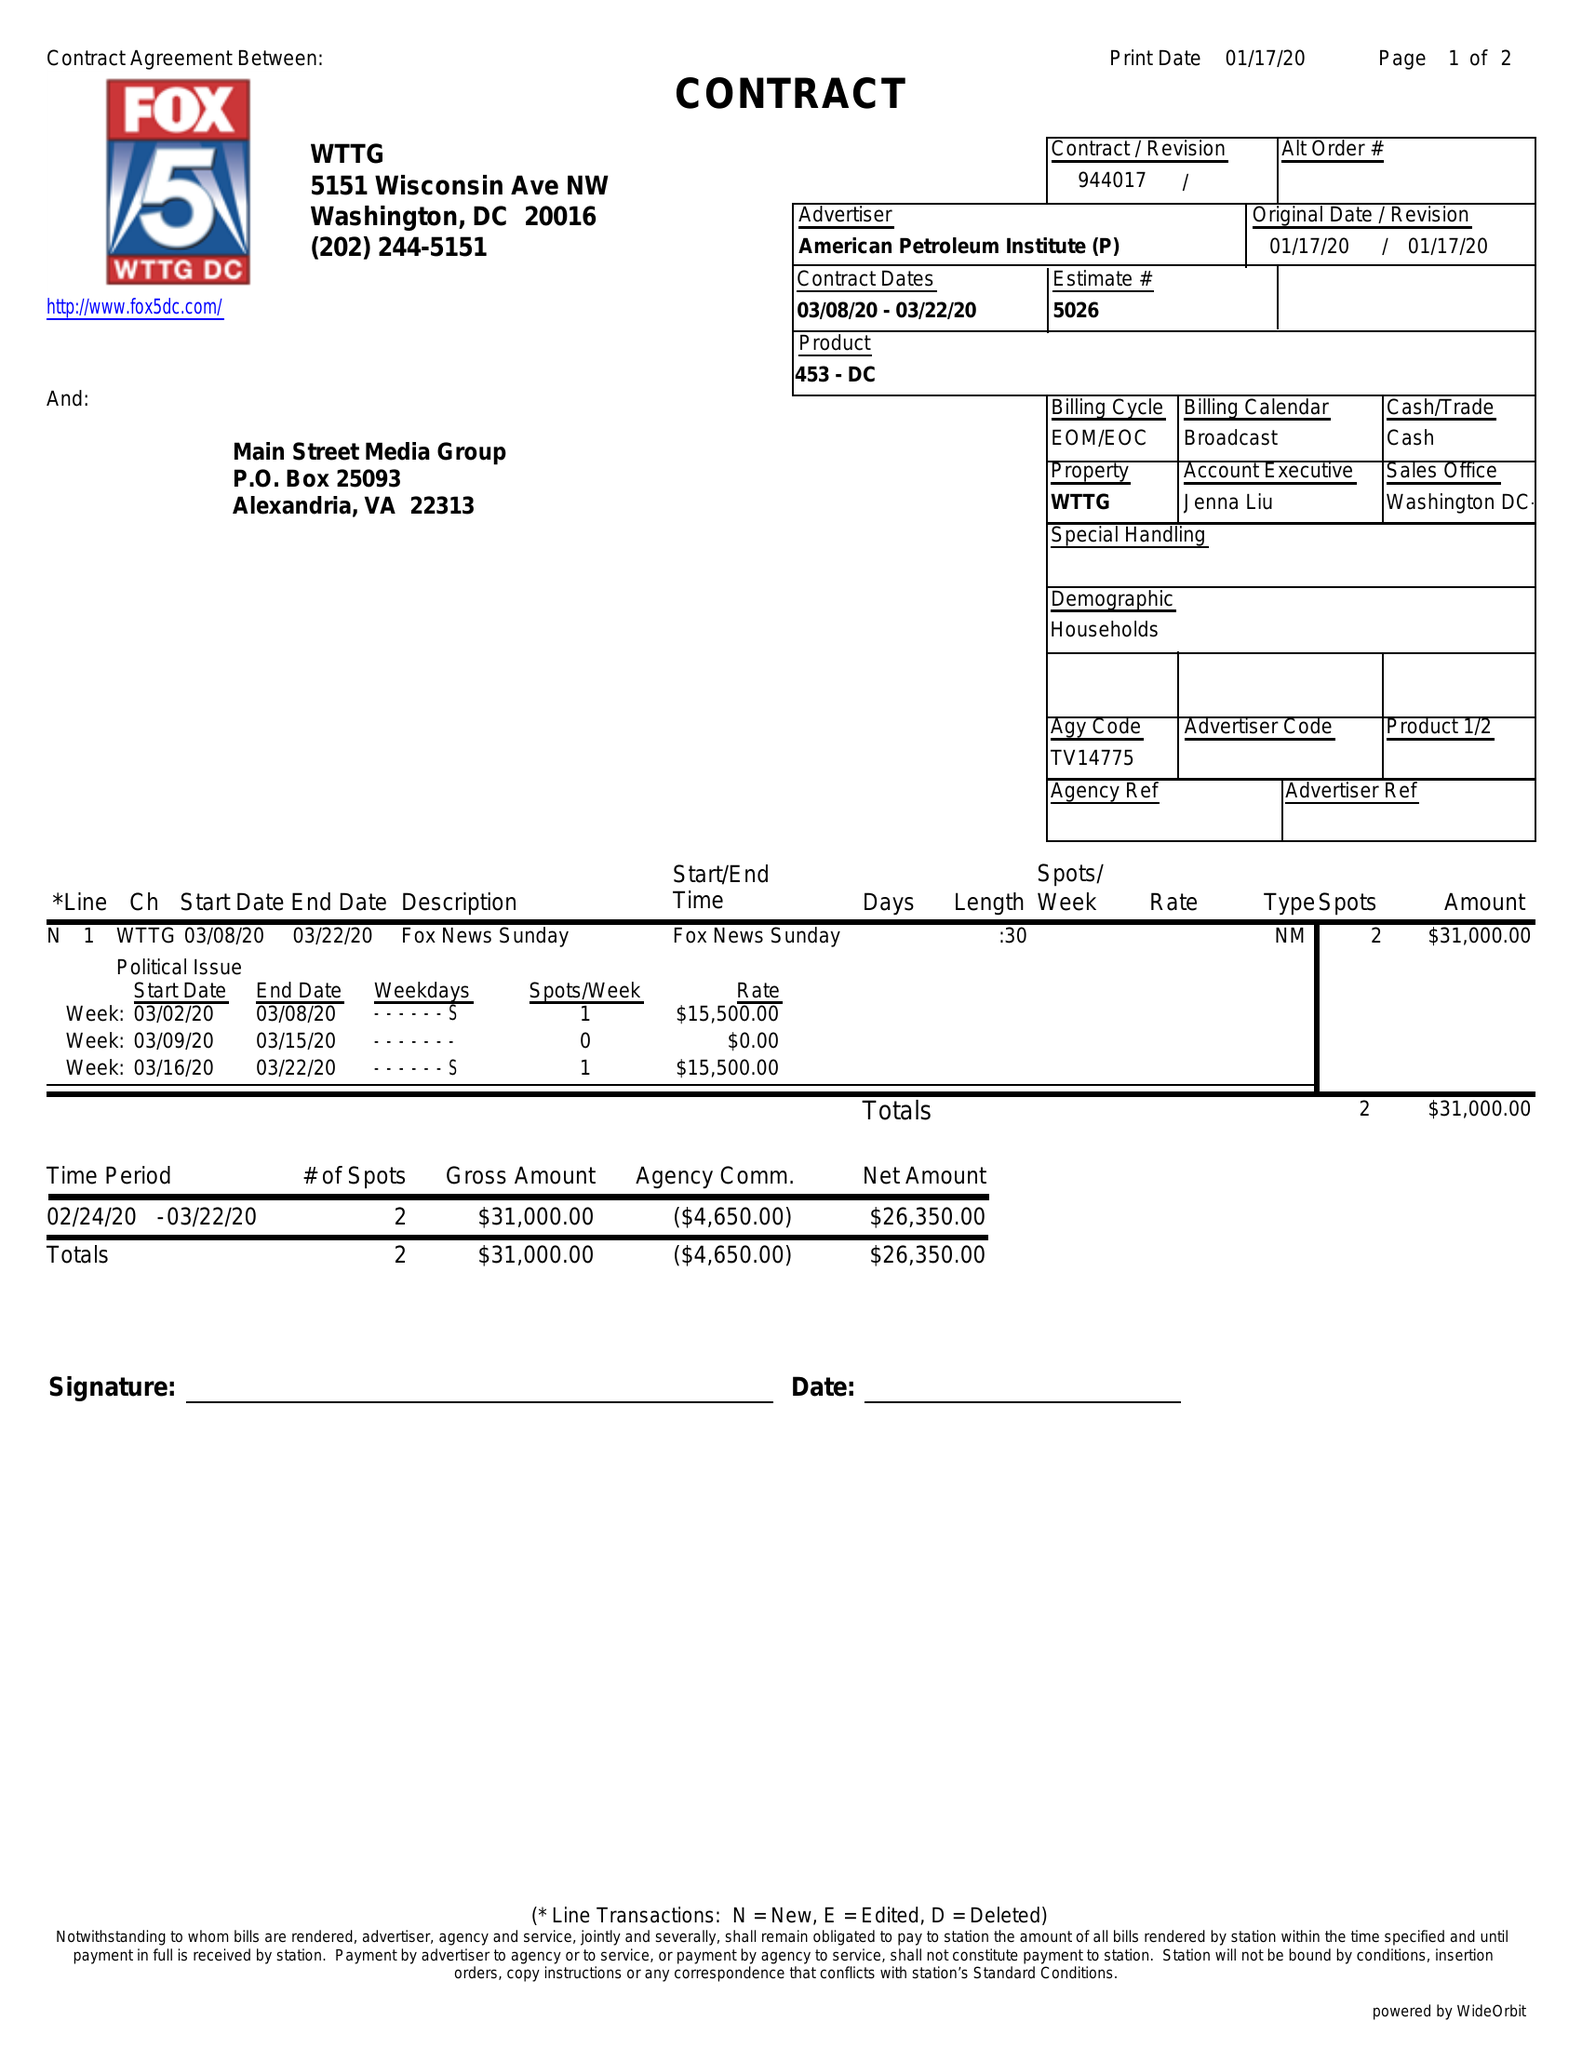What is the value for the advertiser?
Answer the question using a single word or phrase. AMERICAN PETROLEUM INSTITUTE (P) 